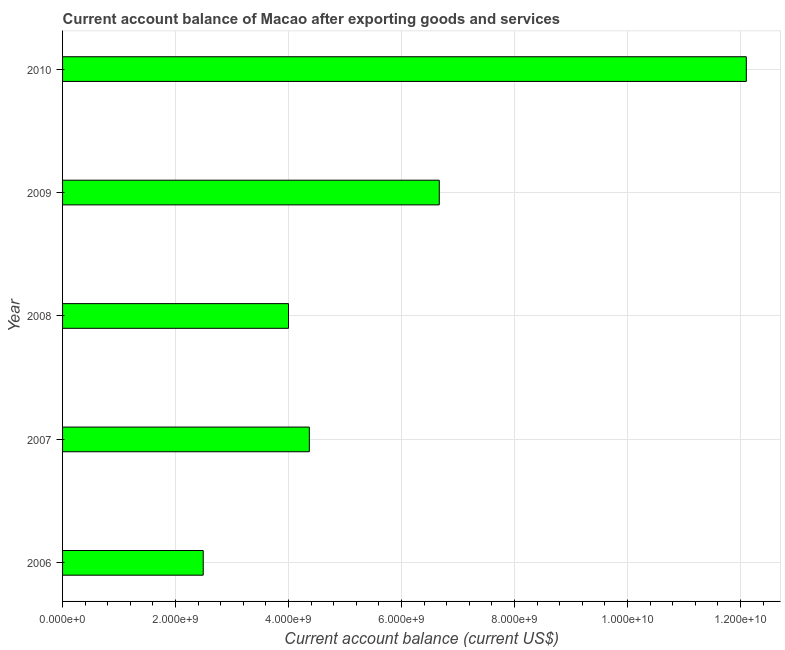Does the graph contain any zero values?
Give a very brief answer. No. What is the title of the graph?
Offer a very short reply. Current account balance of Macao after exporting goods and services. What is the label or title of the X-axis?
Your response must be concise. Current account balance (current US$). What is the current account balance in 2010?
Give a very brief answer. 1.21e+1. Across all years, what is the maximum current account balance?
Make the answer very short. 1.21e+1. Across all years, what is the minimum current account balance?
Offer a very short reply. 2.49e+09. In which year was the current account balance maximum?
Provide a short and direct response. 2010. In which year was the current account balance minimum?
Provide a short and direct response. 2006. What is the sum of the current account balance?
Your answer should be very brief. 2.96e+1. What is the difference between the current account balance in 2007 and 2010?
Your answer should be very brief. -7.74e+09. What is the average current account balance per year?
Your answer should be compact. 5.93e+09. What is the median current account balance?
Ensure brevity in your answer.  4.37e+09. What is the ratio of the current account balance in 2007 to that in 2010?
Offer a terse response. 0.36. Is the current account balance in 2007 less than that in 2009?
Your response must be concise. Yes. What is the difference between the highest and the second highest current account balance?
Offer a very short reply. 5.44e+09. Is the sum of the current account balance in 2008 and 2010 greater than the maximum current account balance across all years?
Provide a short and direct response. Yes. What is the difference between the highest and the lowest current account balance?
Make the answer very short. 9.61e+09. How many bars are there?
Your answer should be very brief. 5. What is the difference between two consecutive major ticks on the X-axis?
Ensure brevity in your answer.  2.00e+09. What is the Current account balance (current US$) in 2006?
Your answer should be very brief. 2.49e+09. What is the Current account balance (current US$) of 2007?
Your answer should be very brief. 4.37e+09. What is the Current account balance (current US$) of 2008?
Offer a terse response. 4.00e+09. What is the Current account balance (current US$) in 2009?
Make the answer very short. 6.67e+09. What is the Current account balance (current US$) in 2010?
Ensure brevity in your answer.  1.21e+1. What is the difference between the Current account balance (current US$) in 2006 and 2007?
Offer a very short reply. -1.88e+09. What is the difference between the Current account balance (current US$) in 2006 and 2008?
Provide a short and direct response. -1.51e+09. What is the difference between the Current account balance (current US$) in 2006 and 2009?
Provide a short and direct response. -4.18e+09. What is the difference between the Current account balance (current US$) in 2006 and 2010?
Give a very brief answer. -9.61e+09. What is the difference between the Current account balance (current US$) in 2007 and 2008?
Give a very brief answer. 3.69e+08. What is the difference between the Current account balance (current US$) in 2007 and 2009?
Provide a succinct answer. -2.30e+09. What is the difference between the Current account balance (current US$) in 2007 and 2010?
Your answer should be very brief. -7.74e+09. What is the difference between the Current account balance (current US$) in 2008 and 2009?
Offer a terse response. -2.67e+09. What is the difference between the Current account balance (current US$) in 2008 and 2010?
Provide a succinct answer. -8.10e+09. What is the difference between the Current account balance (current US$) in 2009 and 2010?
Your answer should be compact. -5.44e+09. What is the ratio of the Current account balance (current US$) in 2006 to that in 2007?
Keep it short and to the point. 0.57. What is the ratio of the Current account balance (current US$) in 2006 to that in 2008?
Offer a very short reply. 0.62. What is the ratio of the Current account balance (current US$) in 2006 to that in 2009?
Keep it short and to the point. 0.37. What is the ratio of the Current account balance (current US$) in 2006 to that in 2010?
Make the answer very short. 0.21. What is the ratio of the Current account balance (current US$) in 2007 to that in 2008?
Your answer should be compact. 1.09. What is the ratio of the Current account balance (current US$) in 2007 to that in 2009?
Your answer should be very brief. 0.66. What is the ratio of the Current account balance (current US$) in 2007 to that in 2010?
Provide a short and direct response. 0.36. What is the ratio of the Current account balance (current US$) in 2008 to that in 2010?
Your response must be concise. 0.33. What is the ratio of the Current account balance (current US$) in 2009 to that in 2010?
Provide a succinct answer. 0.55. 